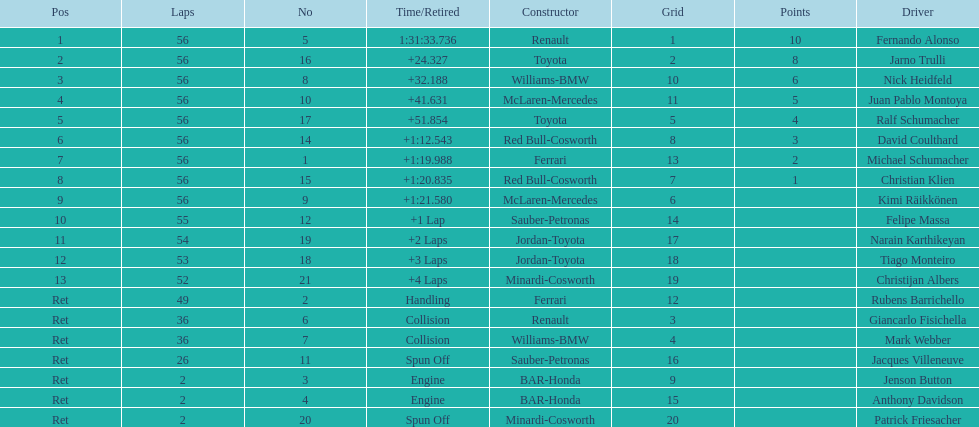How long did it take for heidfeld to finish? 1:31:65.924. 